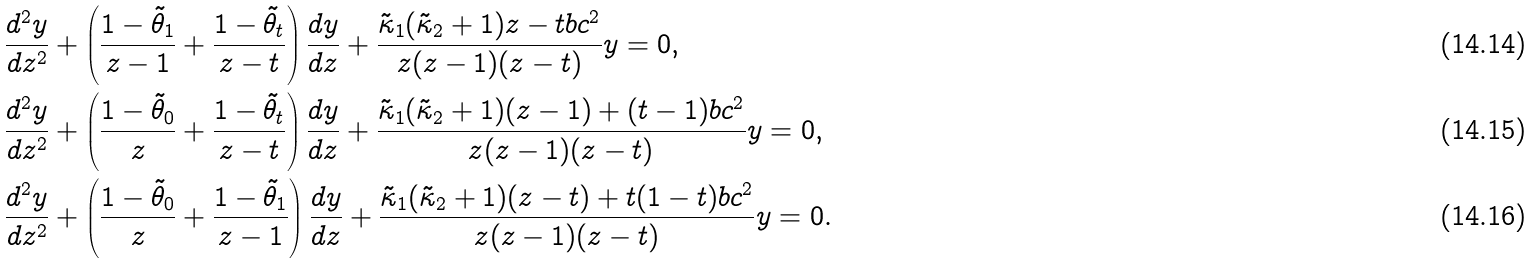<formula> <loc_0><loc_0><loc_500><loc_500>& \frac { d ^ { 2 } y } { d z ^ { 2 } } + \left ( \frac { 1 - \tilde { \theta } _ { 1 } } { z - 1 } + \frac { 1 - \tilde { \theta } _ { t } } { z - t } \right ) \frac { d y } { d z } + \frac { \tilde { \kappa } _ { 1 } ( \tilde { \kappa } _ { 2 } + 1 ) z - t b c ^ { 2 } } { z ( z - 1 ) ( z - t ) } y = 0 , \\ & \frac { d ^ { 2 } y } { d z ^ { 2 } } + \left ( \frac { 1 - \tilde { \theta } _ { 0 } } { z } + \frac { 1 - \tilde { \theta } _ { t } } { z - t } \right ) \frac { d y } { d z } + \frac { \tilde { \kappa } _ { 1 } ( \tilde { \kappa } _ { 2 } + 1 ) ( z - 1 ) + ( t - 1 ) b c ^ { 2 } } { z ( z - 1 ) ( z - t ) } y = 0 , \\ & \frac { d ^ { 2 } y } { d z ^ { 2 } } + \left ( \frac { 1 - \tilde { \theta } _ { 0 } } { z } + \frac { 1 - \tilde { \theta } _ { 1 } } { z - 1 } \right ) \frac { d y } { d z } + \frac { \tilde { \kappa } _ { 1 } ( \tilde { \kappa } _ { 2 } + 1 ) ( z - t ) + t ( 1 - t ) b c ^ { 2 } } { z ( z - 1 ) ( z - t ) } y = 0 .</formula> 